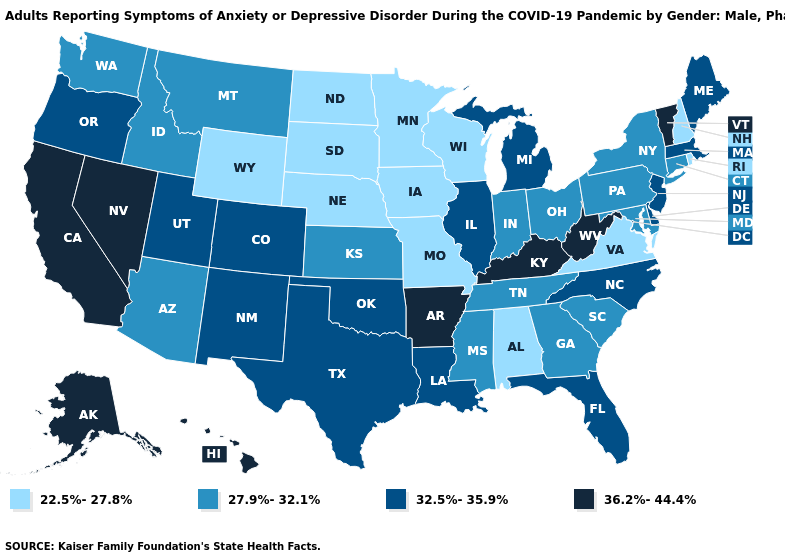Name the states that have a value in the range 32.5%-35.9%?
Short answer required. Colorado, Delaware, Florida, Illinois, Louisiana, Maine, Massachusetts, Michigan, New Jersey, New Mexico, North Carolina, Oklahoma, Oregon, Texas, Utah. Is the legend a continuous bar?
Be succinct. No. What is the value of New York?
Be succinct. 27.9%-32.1%. What is the value of Hawaii?
Write a very short answer. 36.2%-44.4%. What is the highest value in the USA?
Keep it brief. 36.2%-44.4%. What is the value of Idaho?
Write a very short answer. 27.9%-32.1%. What is the highest value in the USA?
Be succinct. 36.2%-44.4%. What is the lowest value in states that border Washington?
Quick response, please. 27.9%-32.1%. Name the states that have a value in the range 32.5%-35.9%?
Answer briefly. Colorado, Delaware, Florida, Illinois, Louisiana, Maine, Massachusetts, Michigan, New Jersey, New Mexico, North Carolina, Oklahoma, Oregon, Texas, Utah. What is the lowest value in the USA?
Write a very short answer. 22.5%-27.8%. Does Arizona have the lowest value in the USA?
Answer briefly. No. Does the first symbol in the legend represent the smallest category?
Quick response, please. Yes. Name the states that have a value in the range 27.9%-32.1%?
Give a very brief answer. Arizona, Connecticut, Georgia, Idaho, Indiana, Kansas, Maryland, Mississippi, Montana, New York, Ohio, Pennsylvania, South Carolina, Tennessee, Washington. Name the states that have a value in the range 27.9%-32.1%?
Be succinct. Arizona, Connecticut, Georgia, Idaho, Indiana, Kansas, Maryland, Mississippi, Montana, New York, Ohio, Pennsylvania, South Carolina, Tennessee, Washington. What is the value of Montana?
Answer briefly. 27.9%-32.1%. 